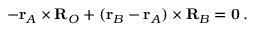Convert formula to latex. <formula><loc_0><loc_0><loc_500><loc_500>- r _ { A } \times R _ { O } + ( r _ { B } - r _ { A } ) \times R _ { B } = 0 \, .</formula> 